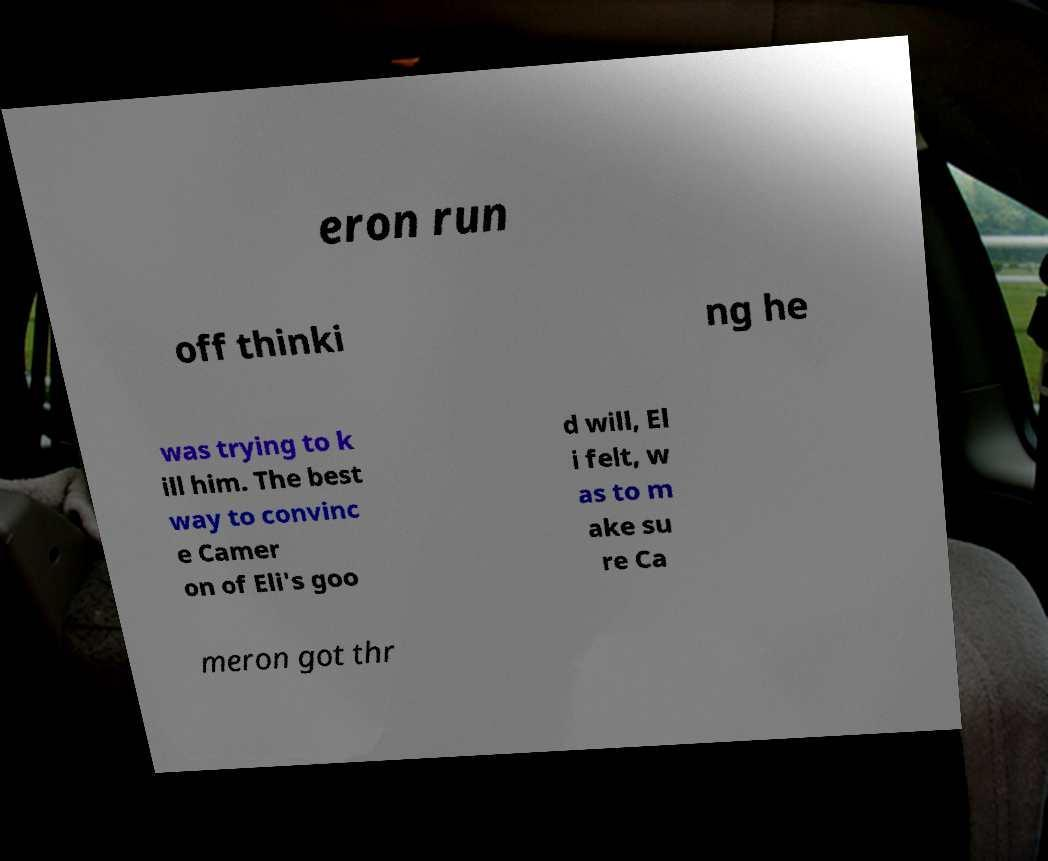For documentation purposes, I need the text within this image transcribed. Could you provide that? eron run off thinki ng he was trying to k ill him. The best way to convinc e Camer on of Eli's goo d will, El i felt, w as to m ake su re Ca meron got thr 